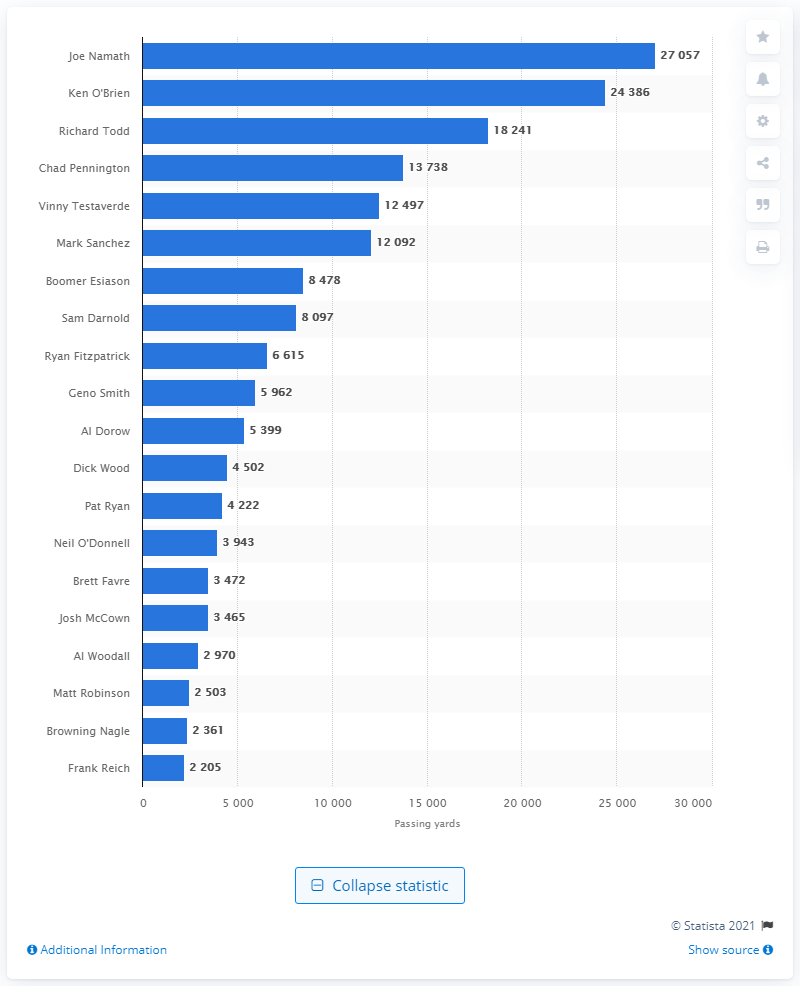Indicate a few pertinent items in this graphic. Joe Namath is the career passing leader of the New York Jets. 